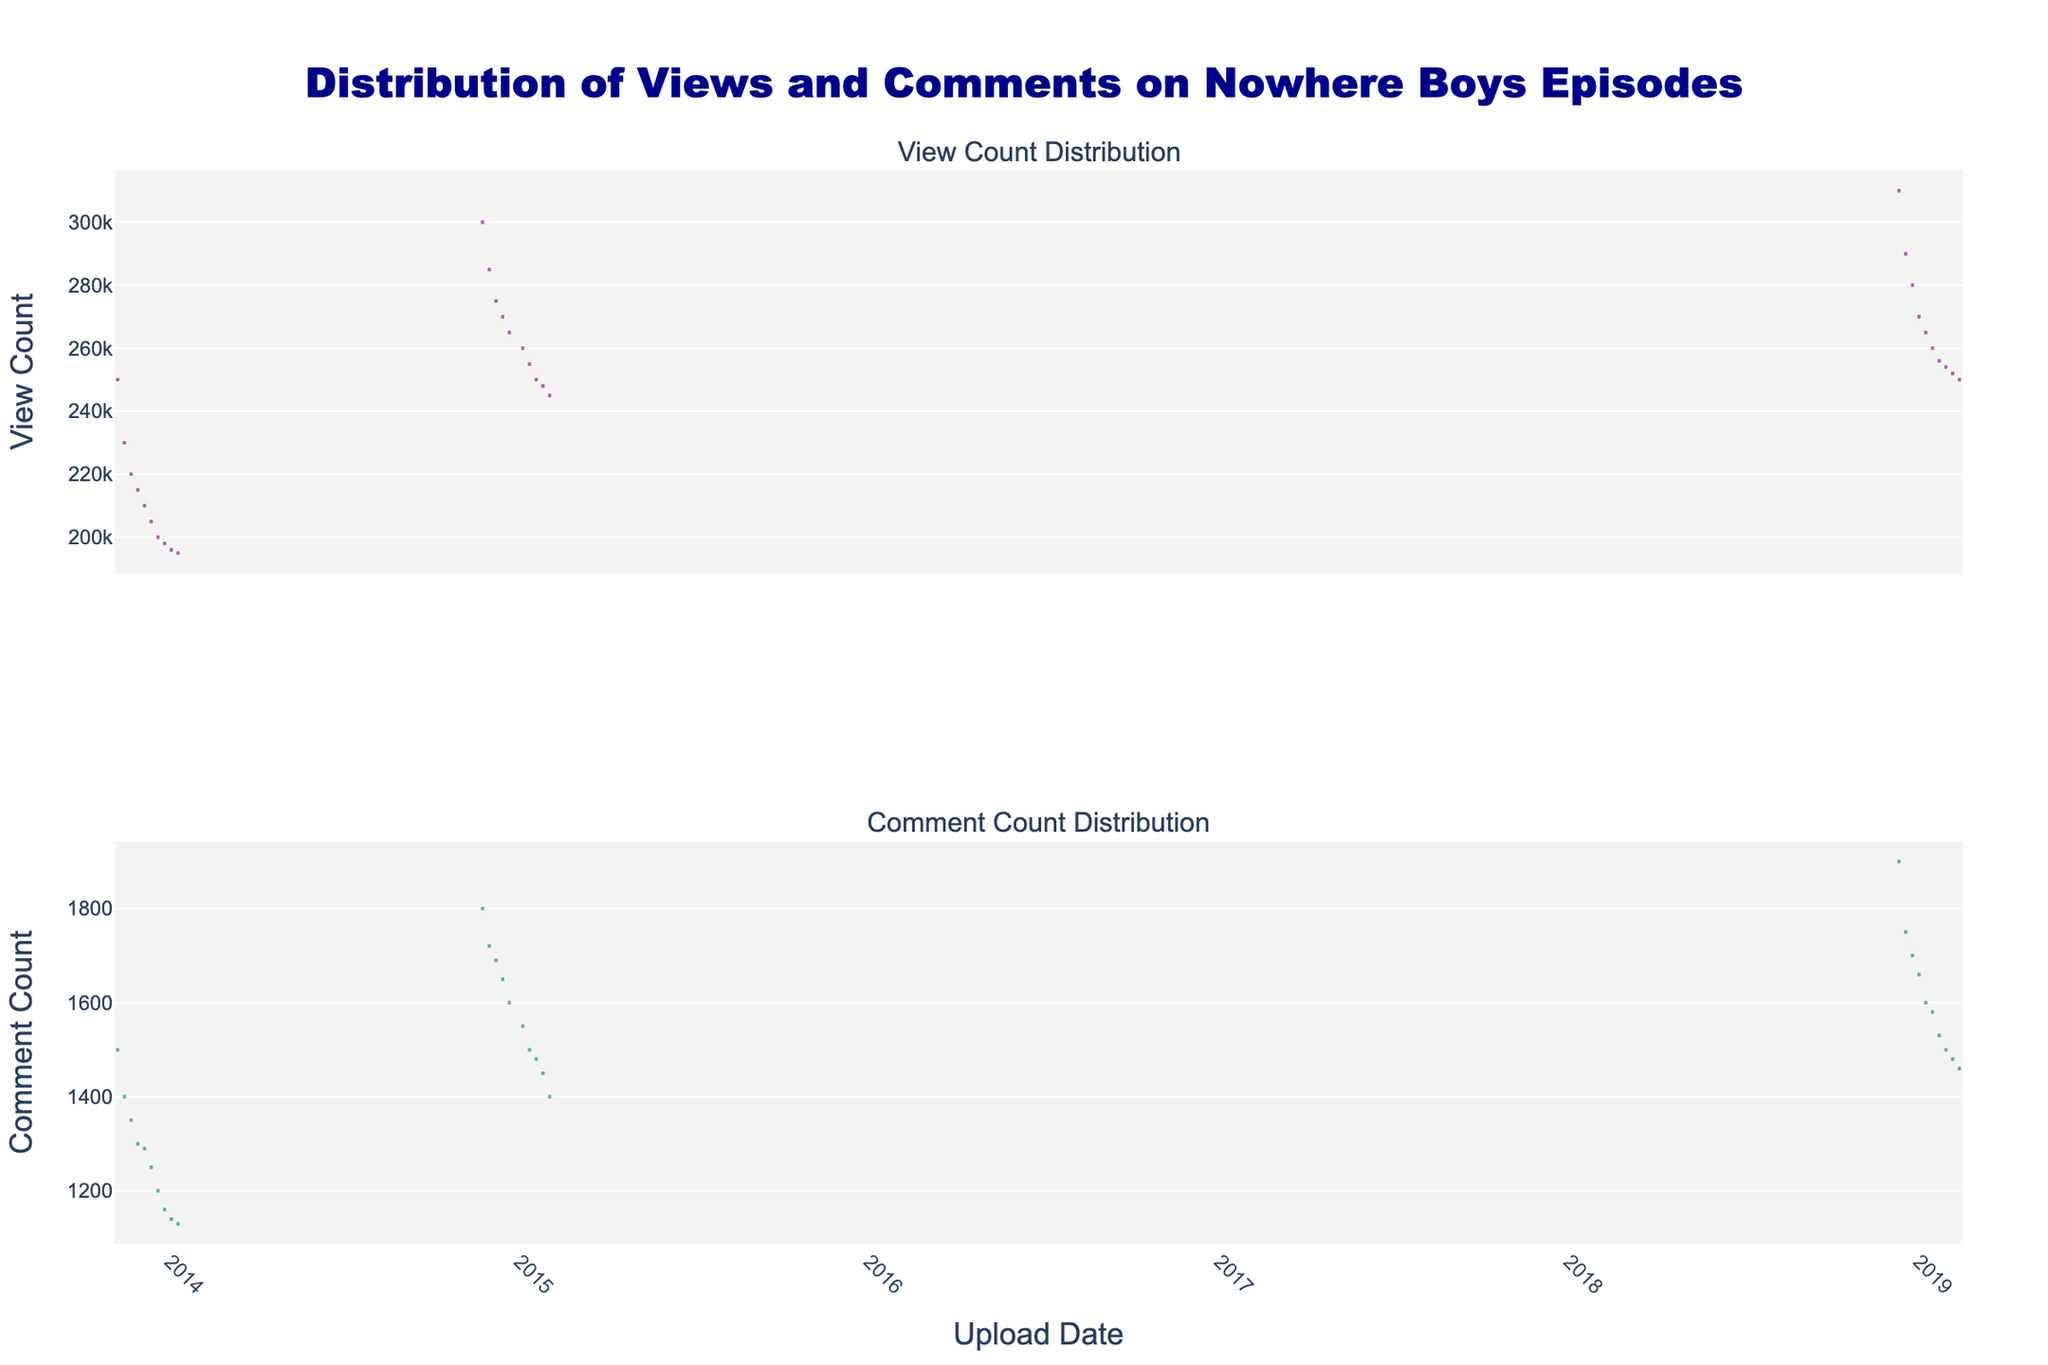When is the highest view count observed? The highest view count can be seen from the violin plot on the top, and it corresponds to the first episode of Season 3.
Answer: December 11, 2018 How do the view counts differ between Season 1 and Season 3 based on the violin plot? Season 1 starts with higher view counts around 250,000 and gradually decreases. In contrast, Season 3 starts higher at 310,000 and also decreases but at a higher overall initial view count.
Answer: Season 3 higher initial view count, gradual decrease What is the trend in view counts over all seasons? Observing the overall trend, each season shows a general decrease in view counts over time, with the initial episodes of each season having the highest counts.
Answer: Decreasing trend over time Which season has the highest average comment count? By examining the mean line in the violin plots for the comment counts, Season 3 shows the highest mean line, indicating the highest average comment count.
Answer: Season 3 How does the median view count of Season 2 compare to Season 1? The median line within the box of the Season 2 plot for view counts is visibly higher than that of Season 1, indicating a higher median view count for Season 2.
Answer: Season 2 higher Do comment counts decrease similarly to view counts over time? Both plots show a decreasing trend over time, but comment counts appear to fall at a slower rate compared to view counts.
Answer: Comment counts decrease slower What is the coloration used for the view count and comment count plots, and what does it signify? The view count plot is colored in purple with a lavender fill, and the comment count plot is colored in teal with a light cyan fill, likely to distinguish between the two metrics.
Answer: Purple: view count, Teal: comment count How often do the average view counts exceed 250,000? From the violin plots, it's clear that most episodes in Season 3 and the initial episodes of each season have average view counts exceeding 250,000.
Answer: Season 3, initial episodes What can be inferred about the audience engagement from the comment count plot? Higher comment counts in earlier episodes suggest greater initial audience engagement, tapering off similarly to view counts.
Answer: High initial engagement Which season shows the greatest variability in view counts? Season 3 shows the greatest spread in view counts, indicating high variability, while other seasons have smaller interquartile ranges.
Answer: Season 3 